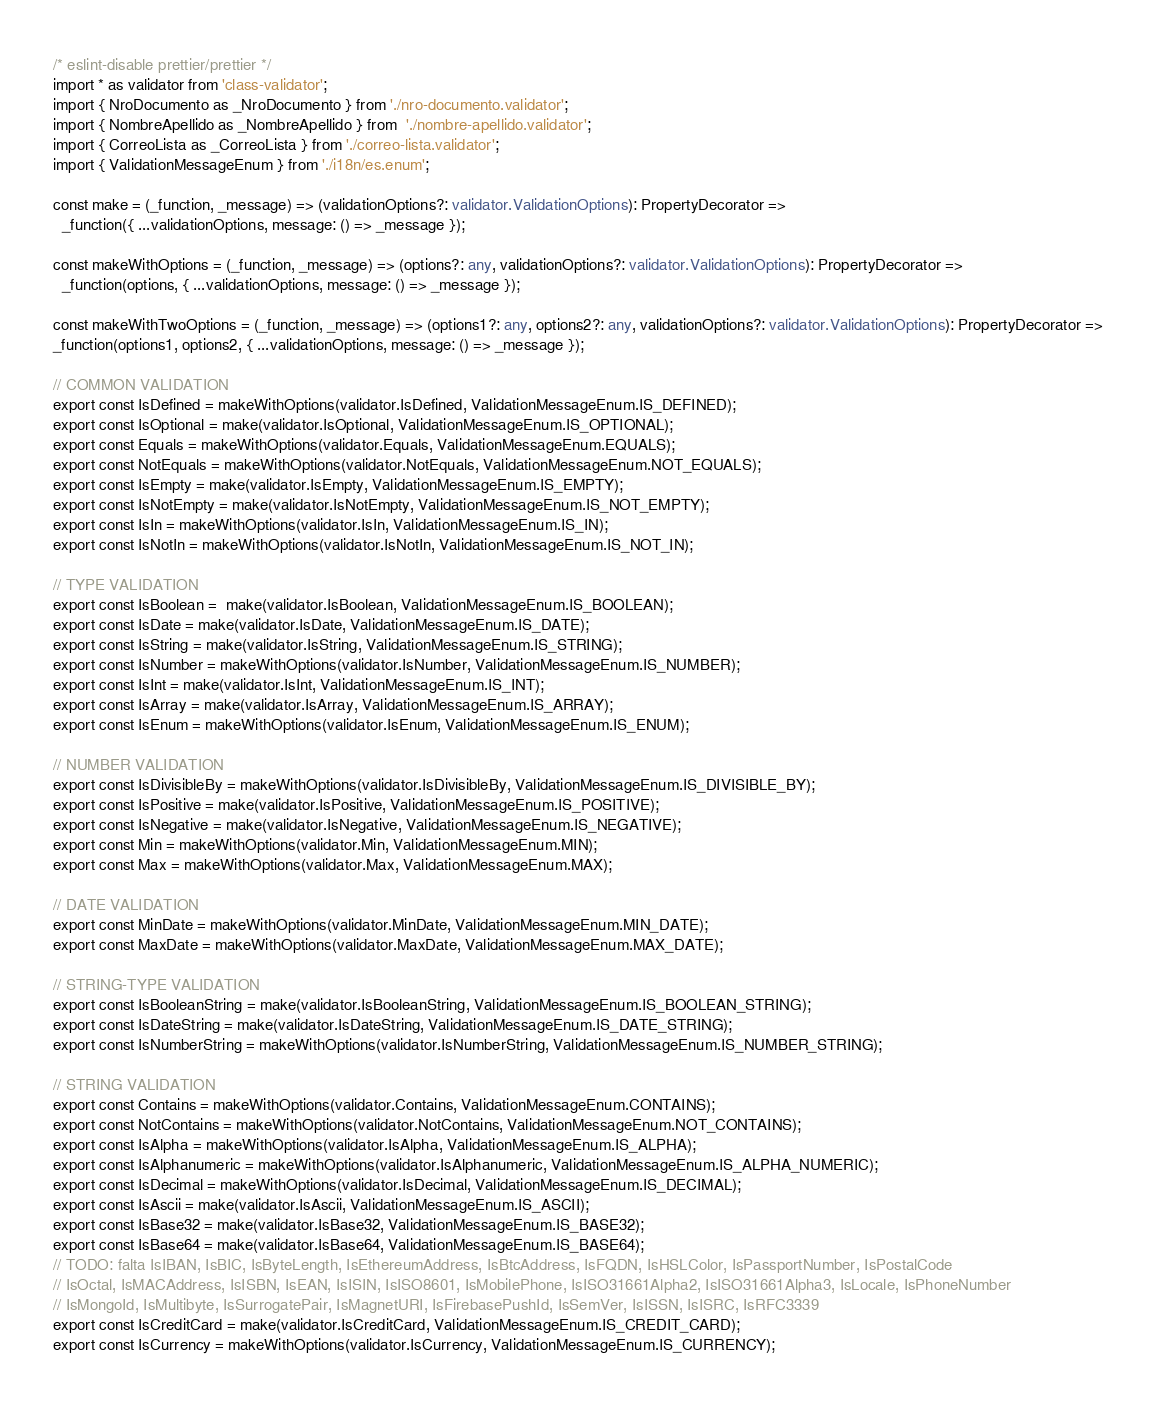Convert code to text. <code><loc_0><loc_0><loc_500><loc_500><_TypeScript_>/* eslint-disable prettier/prettier */
import * as validator from 'class-validator';
import { NroDocumento as _NroDocumento } from './nro-documento.validator';
import { NombreApellido as _NombreApellido } from  './nombre-apellido.validator';
import { CorreoLista as _CorreoLista } from './correo-lista.validator';
import { ValidationMessageEnum } from './i18n/es.enum';

const make = (_function, _message) => (validationOptions?: validator.ValidationOptions): PropertyDecorator => 
  _function({ ...validationOptions, message: () => _message });

const makeWithOptions = (_function, _message) => (options?: any, validationOptions?: validator.ValidationOptions): PropertyDecorator => 
  _function(options, { ...validationOptions, message: () => _message });

const makeWithTwoOptions = (_function, _message) => (options1?: any, options2?: any, validationOptions?: validator.ValidationOptions): PropertyDecorator => 
_function(options1, options2, { ...validationOptions, message: () => _message });

// COMMON VALIDATION
export const IsDefined = makeWithOptions(validator.IsDefined, ValidationMessageEnum.IS_DEFINED);
export const IsOptional = make(validator.IsOptional, ValidationMessageEnum.IS_OPTIONAL);
export const Equals = makeWithOptions(validator.Equals, ValidationMessageEnum.EQUALS);
export const NotEquals = makeWithOptions(validator.NotEquals, ValidationMessageEnum.NOT_EQUALS);
export const IsEmpty = make(validator.IsEmpty, ValidationMessageEnum.IS_EMPTY);
export const IsNotEmpty = make(validator.IsNotEmpty, ValidationMessageEnum.IS_NOT_EMPTY);
export const IsIn = makeWithOptions(validator.IsIn, ValidationMessageEnum.IS_IN);
export const IsNotIn = makeWithOptions(validator.IsNotIn, ValidationMessageEnum.IS_NOT_IN);

// TYPE VALIDATION
export const IsBoolean =  make(validator.IsBoolean, ValidationMessageEnum.IS_BOOLEAN);
export const IsDate = make(validator.IsDate, ValidationMessageEnum.IS_DATE);
export const IsString = make(validator.IsString, ValidationMessageEnum.IS_STRING);
export const IsNumber = makeWithOptions(validator.IsNumber, ValidationMessageEnum.IS_NUMBER);
export const IsInt = make(validator.IsInt, ValidationMessageEnum.IS_INT);
export const IsArray = make(validator.IsArray, ValidationMessageEnum.IS_ARRAY);
export const IsEnum = makeWithOptions(validator.IsEnum, ValidationMessageEnum.IS_ENUM);

// NUMBER VALIDATION
export const IsDivisibleBy = makeWithOptions(validator.IsDivisibleBy, ValidationMessageEnum.IS_DIVISIBLE_BY);
export const IsPositive = make(validator.IsPositive, ValidationMessageEnum.IS_POSITIVE);
export const IsNegative = make(validator.IsNegative, ValidationMessageEnum.IS_NEGATIVE);
export const Min = makeWithOptions(validator.Min, ValidationMessageEnum.MIN);
export const Max = makeWithOptions(validator.Max, ValidationMessageEnum.MAX);

// DATE VALIDATION
export const MinDate = makeWithOptions(validator.MinDate, ValidationMessageEnum.MIN_DATE);
export const MaxDate = makeWithOptions(validator.MaxDate, ValidationMessageEnum.MAX_DATE);

// STRING-TYPE VALIDATION
export const IsBooleanString = make(validator.IsBooleanString, ValidationMessageEnum.IS_BOOLEAN_STRING);
export const IsDateString = make(validator.IsDateString, ValidationMessageEnum.IS_DATE_STRING);
export const IsNumberString = makeWithOptions(validator.IsNumberString, ValidationMessageEnum.IS_NUMBER_STRING);

// STRING VALIDATION
export const Contains = makeWithOptions(validator.Contains, ValidationMessageEnum.CONTAINS);
export const NotContains = makeWithOptions(validator.NotContains, ValidationMessageEnum.NOT_CONTAINS);
export const IsAlpha = makeWithOptions(validator.IsAlpha, ValidationMessageEnum.IS_ALPHA);
export const IsAlphanumeric = makeWithOptions(validator.IsAlphanumeric, ValidationMessageEnum.IS_ALPHA_NUMERIC);
export const IsDecimal = makeWithOptions(validator.IsDecimal, ValidationMessageEnum.IS_DECIMAL);
export const IsAscii = make(validator.IsAscii, ValidationMessageEnum.IS_ASCII);
export const IsBase32 = make(validator.IsBase32, ValidationMessageEnum.IS_BASE32);
export const IsBase64 = make(validator.IsBase64, ValidationMessageEnum.IS_BASE64);
// TODO: falta IsIBAN, IsBIC, IsByteLength, IsEthereumAddress, IsBtcAddress, IsFQDN, IsHSLColor, IsPassportNumber, IsPostalCode
// IsOctal, IsMACAddress, IsISBN, IsEAN, IsISIN, IsISO8601, IsMobilePhone, IsISO31661Alpha2, IsISO31661Alpha3, IsLocale, IsPhoneNumber
// IsMongoId, IsMultibyte, IsSurrogatePair, IsMagnetURI, IsFirebasePushId, IsSemVer, IsISSN, IsISRC, IsRFC3339
export const IsCreditCard = make(validator.IsCreditCard, ValidationMessageEnum.IS_CREDIT_CARD);
export const IsCurrency = makeWithOptions(validator.IsCurrency, ValidationMessageEnum.IS_CURRENCY);</code> 